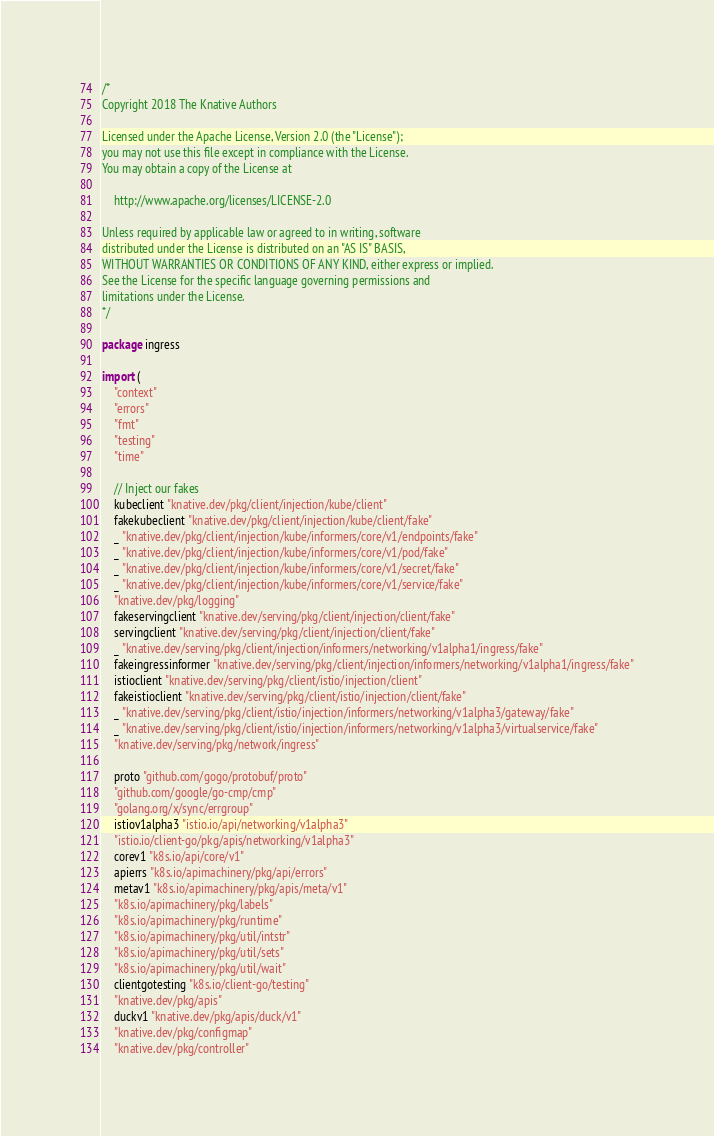<code> <loc_0><loc_0><loc_500><loc_500><_Go_>/*
Copyright 2018 The Knative Authors

Licensed under the Apache License, Version 2.0 (the "License");
you may not use this file except in compliance with the License.
You may obtain a copy of the License at

    http://www.apache.org/licenses/LICENSE-2.0

Unless required by applicable law or agreed to in writing, software
distributed under the License is distributed on an "AS IS" BASIS,
WITHOUT WARRANTIES OR CONDITIONS OF ANY KIND, either express or implied.
See the License for the specific language governing permissions and
limitations under the License.
*/

package ingress

import (
	"context"
	"errors"
	"fmt"
	"testing"
	"time"

	// Inject our fakes
	kubeclient "knative.dev/pkg/client/injection/kube/client"
	fakekubeclient "knative.dev/pkg/client/injection/kube/client/fake"
	_ "knative.dev/pkg/client/injection/kube/informers/core/v1/endpoints/fake"
	_ "knative.dev/pkg/client/injection/kube/informers/core/v1/pod/fake"
	_ "knative.dev/pkg/client/injection/kube/informers/core/v1/secret/fake"
	_ "knative.dev/pkg/client/injection/kube/informers/core/v1/service/fake"
	"knative.dev/pkg/logging"
	fakeservingclient "knative.dev/serving/pkg/client/injection/client/fake"
	servingclient "knative.dev/serving/pkg/client/injection/client/fake"
	_ "knative.dev/serving/pkg/client/injection/informers/networking/v1alpha1/ingress/fake"
	fakeingressinformer "knative.dev/serving/pkg/client/injection/informers/networking/v1alpha1/ingress/fake"
	istioclient "knative.dev/serving/pkg/client/istio/injection/client"
	fakeistioclient "knative.dev/serving/pkg/client/istio/injection/client/fake"
	_ "knative.dev/serving/pkg/client/istio/injection/informers/networking/v1alpha3/gateway/fake"
	_ "knative.dev/serving/pkg/client/istio/injection/informers/networking/v1alpha3/virtualservice/fake"
	"knative.dev/serving/pkg/network/ingress"

	proto "github.com/gogo/protobuf/proto"
	"github.com/google/go-cmp/cmp"
	"golang.org/x/sync/errgroup"
	istiov1alpha3 "istio.io/api/networking/v1alpha3"
	"istio.io/client-go/pkg/apis/networking/v1alpha3"
	corev1 "k8s.io/api/core/v1"
	apierrs "k8s.io/apimachinery/pkg/api/errors"
	metav1 "k8s.io/apimachinery/pkg/apis/meta/v1"
	"k8s.io/apimachinery/pkg/labels"
	"k8s.io/apimachinery/pkg/runtime"
	"k8s.io/apimachinery/pkg/util/intstr"
	"k8s.io/apimachinery/pkg/util/sets"
	"k8s.io/apimachinery/pkg/util/wait"
	clientgotesting "k8s.io/client-go/testing"
	"knative.dev/pkg/apis"
	duckv1 "knative.dev/pkg/apis/duck/v1"
	"knative.dev/pkg/configmap"
	"knative.dev/pkg/controller"</code> 